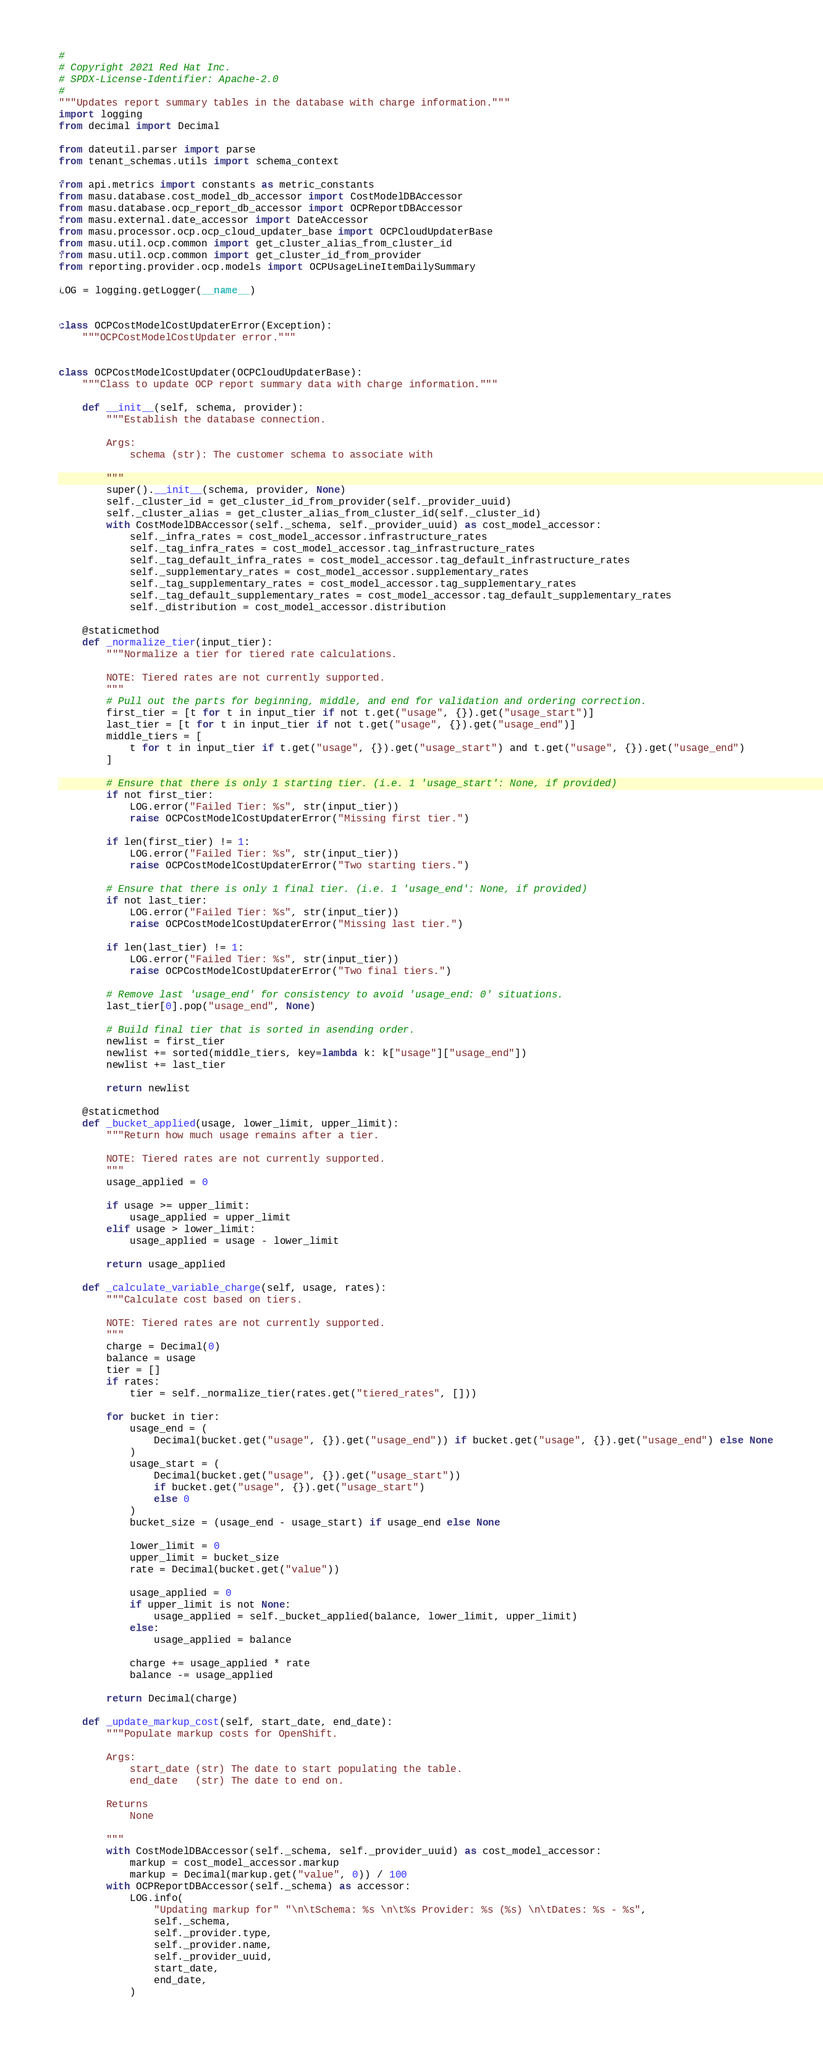Convert code to text. <code><loc_0><loc_0><loc_500><loc_500><_Python_>#
# Copyright 2021 Red Hat Inc.
# SPDX-License-Identifier: Apache-2.0
#
"""Updates report summary tables in the database with charge information."""
import logging
from decimal import Decimal

from dateutil.parser import parse
from tenant_schemas.utils import schema_context

from api.metrics import constants as metric_constants
from masu.database.cost_model_db_accessor import CostModelDBAccessor
from masu.database.ocp_report_db_accessor import OCPReportDBAccessor
from masu.external.date_accessor import DateAccessor
from masu.processor.ocp.ocp_cloud_updater_base import OCPCloudUpdaterBase
from masu.util.ocp.common import get_cluster_alias_from_cluster_id
from masu.util.ocp.common import get_cluster_id_from_provider
from reporting.provider.ocp.models import OCPUsageLineItemDailySummary

LOG = logging.getLogger(__name__)


class OCPCostModelCostUpdaterError(Exception):
    """OCPCostModelCostUpdater error."""


class OCPCostModelCostUpdater(OCPCloudUpdaterBase):
    """Class to update OCP report summary data with charge information."""

    def __init__(self, schema, provider):
        """Establish the database connection.

        Args:
            schema (str): The customer schema to associate with

        """
        super().__init__(schema, provider, None)
        self._cluster_id = get_cluster_id_from_provider(self._provider_uuid)
        self._cluster_alias = get_cluster_alias_from_cluster_id(self._cluster_id)
        with CostModelDBAccessor(self._schema, self._provider_uuid) as cost_model_accessor:
            self._infra_rates = cost_model_accessor.infrastructure_rates
            self._tag_infra_rates = cost_model_accessor.tag_infrastructure_rates
            self._tag_default_infra_rates = cost_model_accessor.tag_default_infrastructure_rates
            self._supplementary_rates = cost_model_accessor.supplementary_rates
            self._tag_supplementary_rates = cost_model_accessor.tag_supplementary_rates
            self._tag_default_supplementary_rates = cost_model_accessor.tag_default_supplementary_rates
            self._distribution = cost_model_accessor.distribution

    @staticmethod
    def _normalize_tier(input_tier):
        """Normalize a tier for tiered rate calculations.

        NOTE: Tiered rates are not currently supported.
        """
        # Pull out the parts for beginning, middle, and end for validation and ordering correction.
        first_tier = [t for t in input_tier if not t.get("usage", {}).get("usage_start")]
        last_tier = [t for t in input_tier if not t.get("usage", {}).get("usage_end")]
        middle_tiers = [
            t for t in input_tier if t.get("usage", {}).get("usage_start") and t.get("usage", {}).get("usage_end")
        ]

        # Ensure that there is only 1 starting tier. (i.e. 1 'usage_start': None, if provided)
        if not first_tier:
            LOG.error("Failed Tier: %s", str(input_tier))
            raise OCPCostModelCostUpdaterError("Missing first tier.")

        if len(first_tier) != 1:
            LOG.error("Failed Tier: %s", str(input_tier))
            raise OCPCostModelCostUpdaterError("Two starting tiers.")

        # Ensure that there is only 1 final tier. (i.e. 1 'usage_end': None, if provided)
        if not last_tier:
            LOG.error("Failed Tier: %s", str(input_tier))
            raise OCPCostModelCostUpdaterError("Missing last tier.")

        if len(last_tier) != 1:
            LOG.error("Failed Tier: %s", str(input_tier))
            raise OCPCostModelCostUpdaterError("Two final tiers.")

        # Remove last 'usage_end' for consistency to avoid 'usage_end: 0' situations.
        last_tier[0].pop("usage_end", None)

        # Build final tier that is sorted in asending order.
        newlist = first_tier
        newlist += sorted(middle_tiers, key=lambda k: k["usage"]["usage_end"])
        newlist += last_tier

        return newlist

    @staticmethod
    def _bucket_applied(usage, lower_limit, upper_limit):
        """Return how much usage remains after a tier.

        NOTE: Tiered rates are not currently supported.
        """
        usage_applied = 0

        if usage >= upper_limit:
            usage_applied = upper_limit
        elif usage > lower_limit:
            usage_applied = usage - lower_limit

        return usage_applied

    def _calculate_variable_charge(self, usage, rates):
        """Calculate cost based on tiers.

        NOTE: Tiered rates are not currently supported.
        """
        charge = Decimal(0)
        balance = usage
        tier = []
        if rates:
            tier = self._normalize_tier(rates.get("tiered_rates", []))

        for bucket in tier:
            usage_end = (
                Decimal(bucket.get("usage", {}).get("usage_end")) if bucket.get("usage", {}).get("usage_end") else None
            )
            usage_start = (
                Decimal(bucket.get("usage", {}).get("usage_start"))
                if bucket.get("usage", {}).get("usage_start")
                else 0
            )
            bucket_size = (usage_end - usage_start) if usage_end else None

            lower_limit = 0
            upper_limit = bucket_size
            rate = Decimal(bucket.get("value"))

            usage_applied = 0
            if upper_limit is not None:
                usage_applied = self._bucket_applied(balance, lower_limit, upper_limit)
            else:
                usage_applied = balance

            charge += usage_applied * rate
            balance -= usage_applied

        return Decimal(charge)

    def _update_markup_cost(self, start_date, end_date):
        """Populate markup costs for OpenShift.

        Args:
            start_date (str) The date to start populating the table.
            end_date   (str) The date to end on.

        Returns
            None

        """
        with CostModelDBAccessor(self._schema, self._provider_uuid) as cost_model_accessor:
            markup = cost_model_accessor.markup
            markup = Decimal(markup.get("value", 0)) / 100
        with OCPReportDBAccessor(self._schema) as accessor:
            LOG.info(
                "Updating markup for" "\n\tSchema: %s \n\t%s Provider: %s (%s) \n\tDates: %s - %s",
                self._schema,
                self._provider.type,
                self._provider.name,
                self._provider_uuid,
                start_date,
                end_date,
            )</code> 